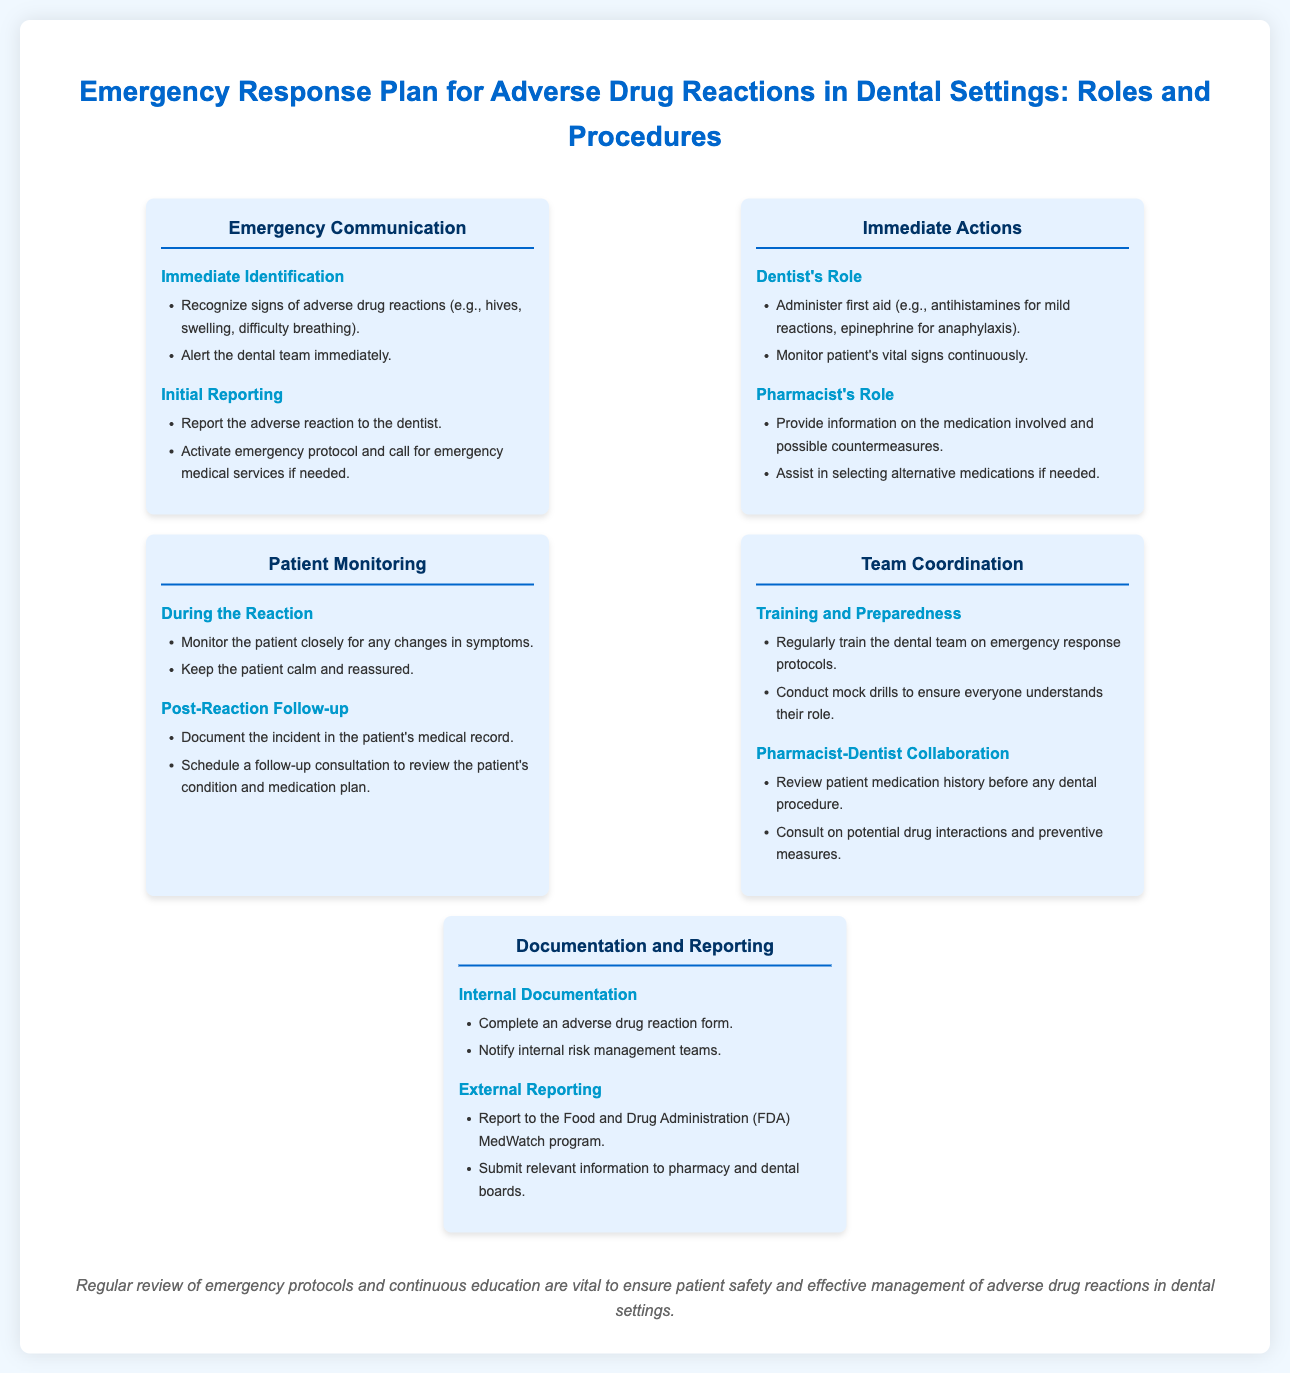What is the title of the infographic? The title of the infographic is stated at the top of the document, which summarizes the content regarding emergency response plans in dental settings.
Answer: Emergency Response Plan for Adverse Drug Reactions in Dental Settings: Roles and Procedures What are the signs of adverse drug reactions? Signs are listed under "Immediate Identification" in the "Emergency Communication" section of the document.
Answer: Hives, swelling, difficulty breathing Who is responsible for administering first aid? This responsibility is outlined under the "Immediate Actions" section, specifically in the "Dentist's Role."
Answer: Dentist What should be done during the patient monitoring phase? This can be found in the "Patient Monitoring" section, during the reaction and post-reaction follow-up.
Answer: Monitor closely for any changes in symptoms What is a critical step in team coordination? This step is highlighted in the "Training and Preparedness" subsection of the "Team Coordination" section.
Answer: Regularly train the dental team on emergency response protocols What is included in internal documentation after an adverse drug reaction? The requirement for internal documentation is mentioned in the "Documentation and Reporting" section under "Internal Documentation."
Answer: Complete an adverse drug reaction form What should the dentist do if a patient shows signs of anaphylaxis? This action is detailed in the "Dentist's Role" under the "Immediate Actions" section.
Answer: Administer epinephrine What is the purpose of pharmacist-dentist collaboration? The collaboration aims are stated in the "Pharmacist-Dentist Collaboration" subsection of the "Team Coordination" section.
Answer: Review patient medication history before any dental procedure 